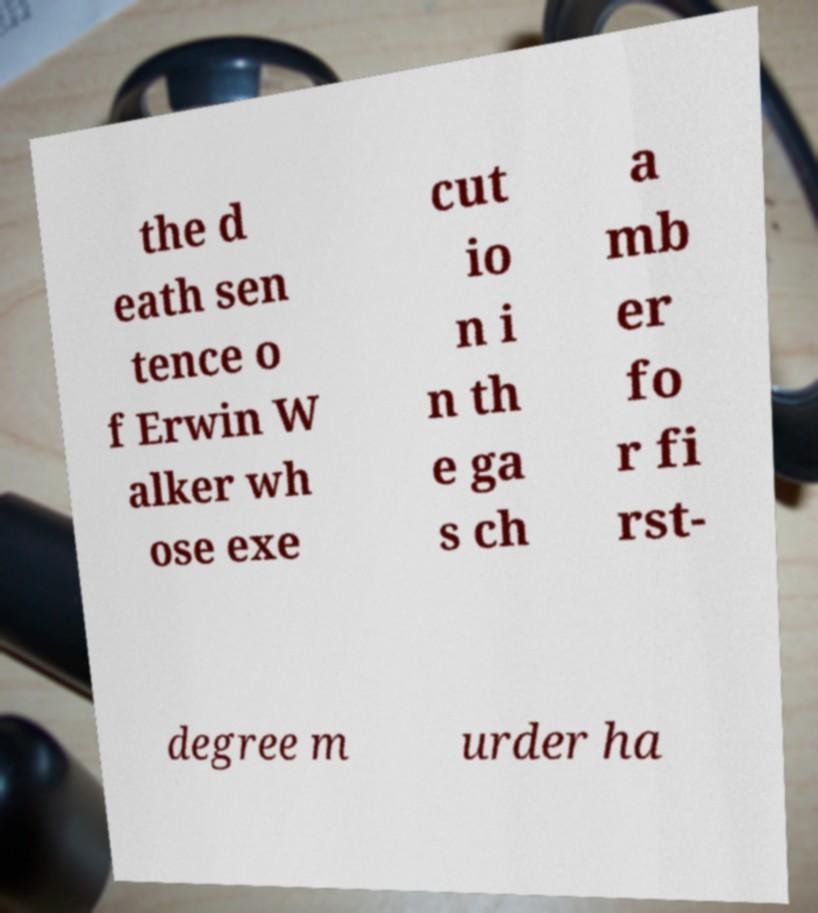I need the written content from this picture converted into text. Can you do that? the d eath sen tence o f Erwin W alker wh ose exe cut io n i n th e ga s ch a mb er fo r fi rst- degree m urder ha 